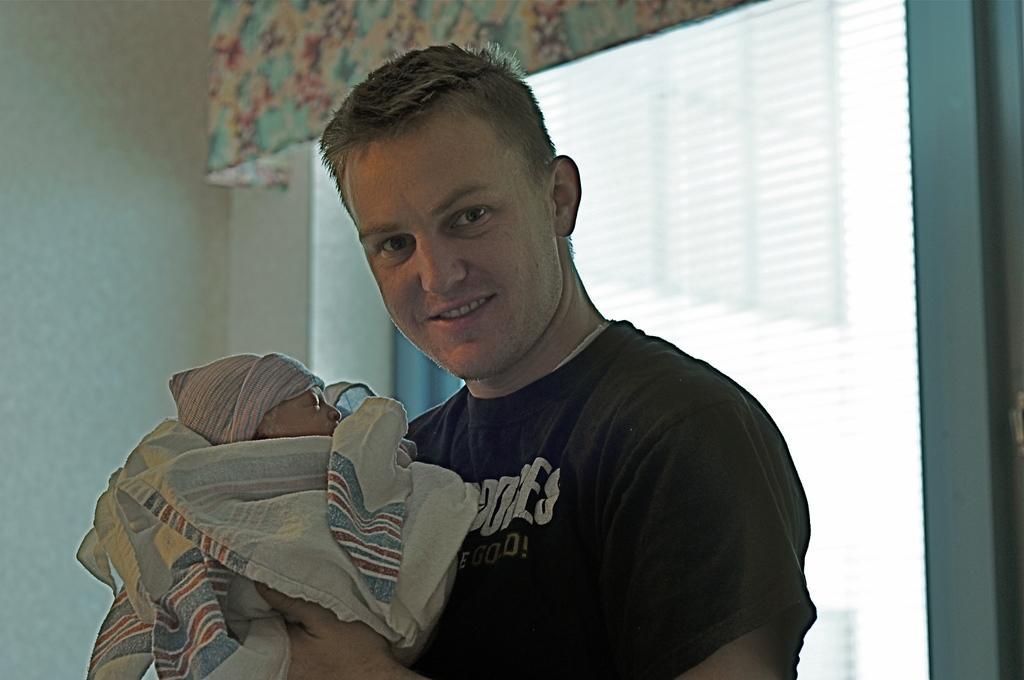Please provide a concise description of this image. In this image we can see a man holding a baby. In the background we can see blinds and there is a curtain. There is a wall. 